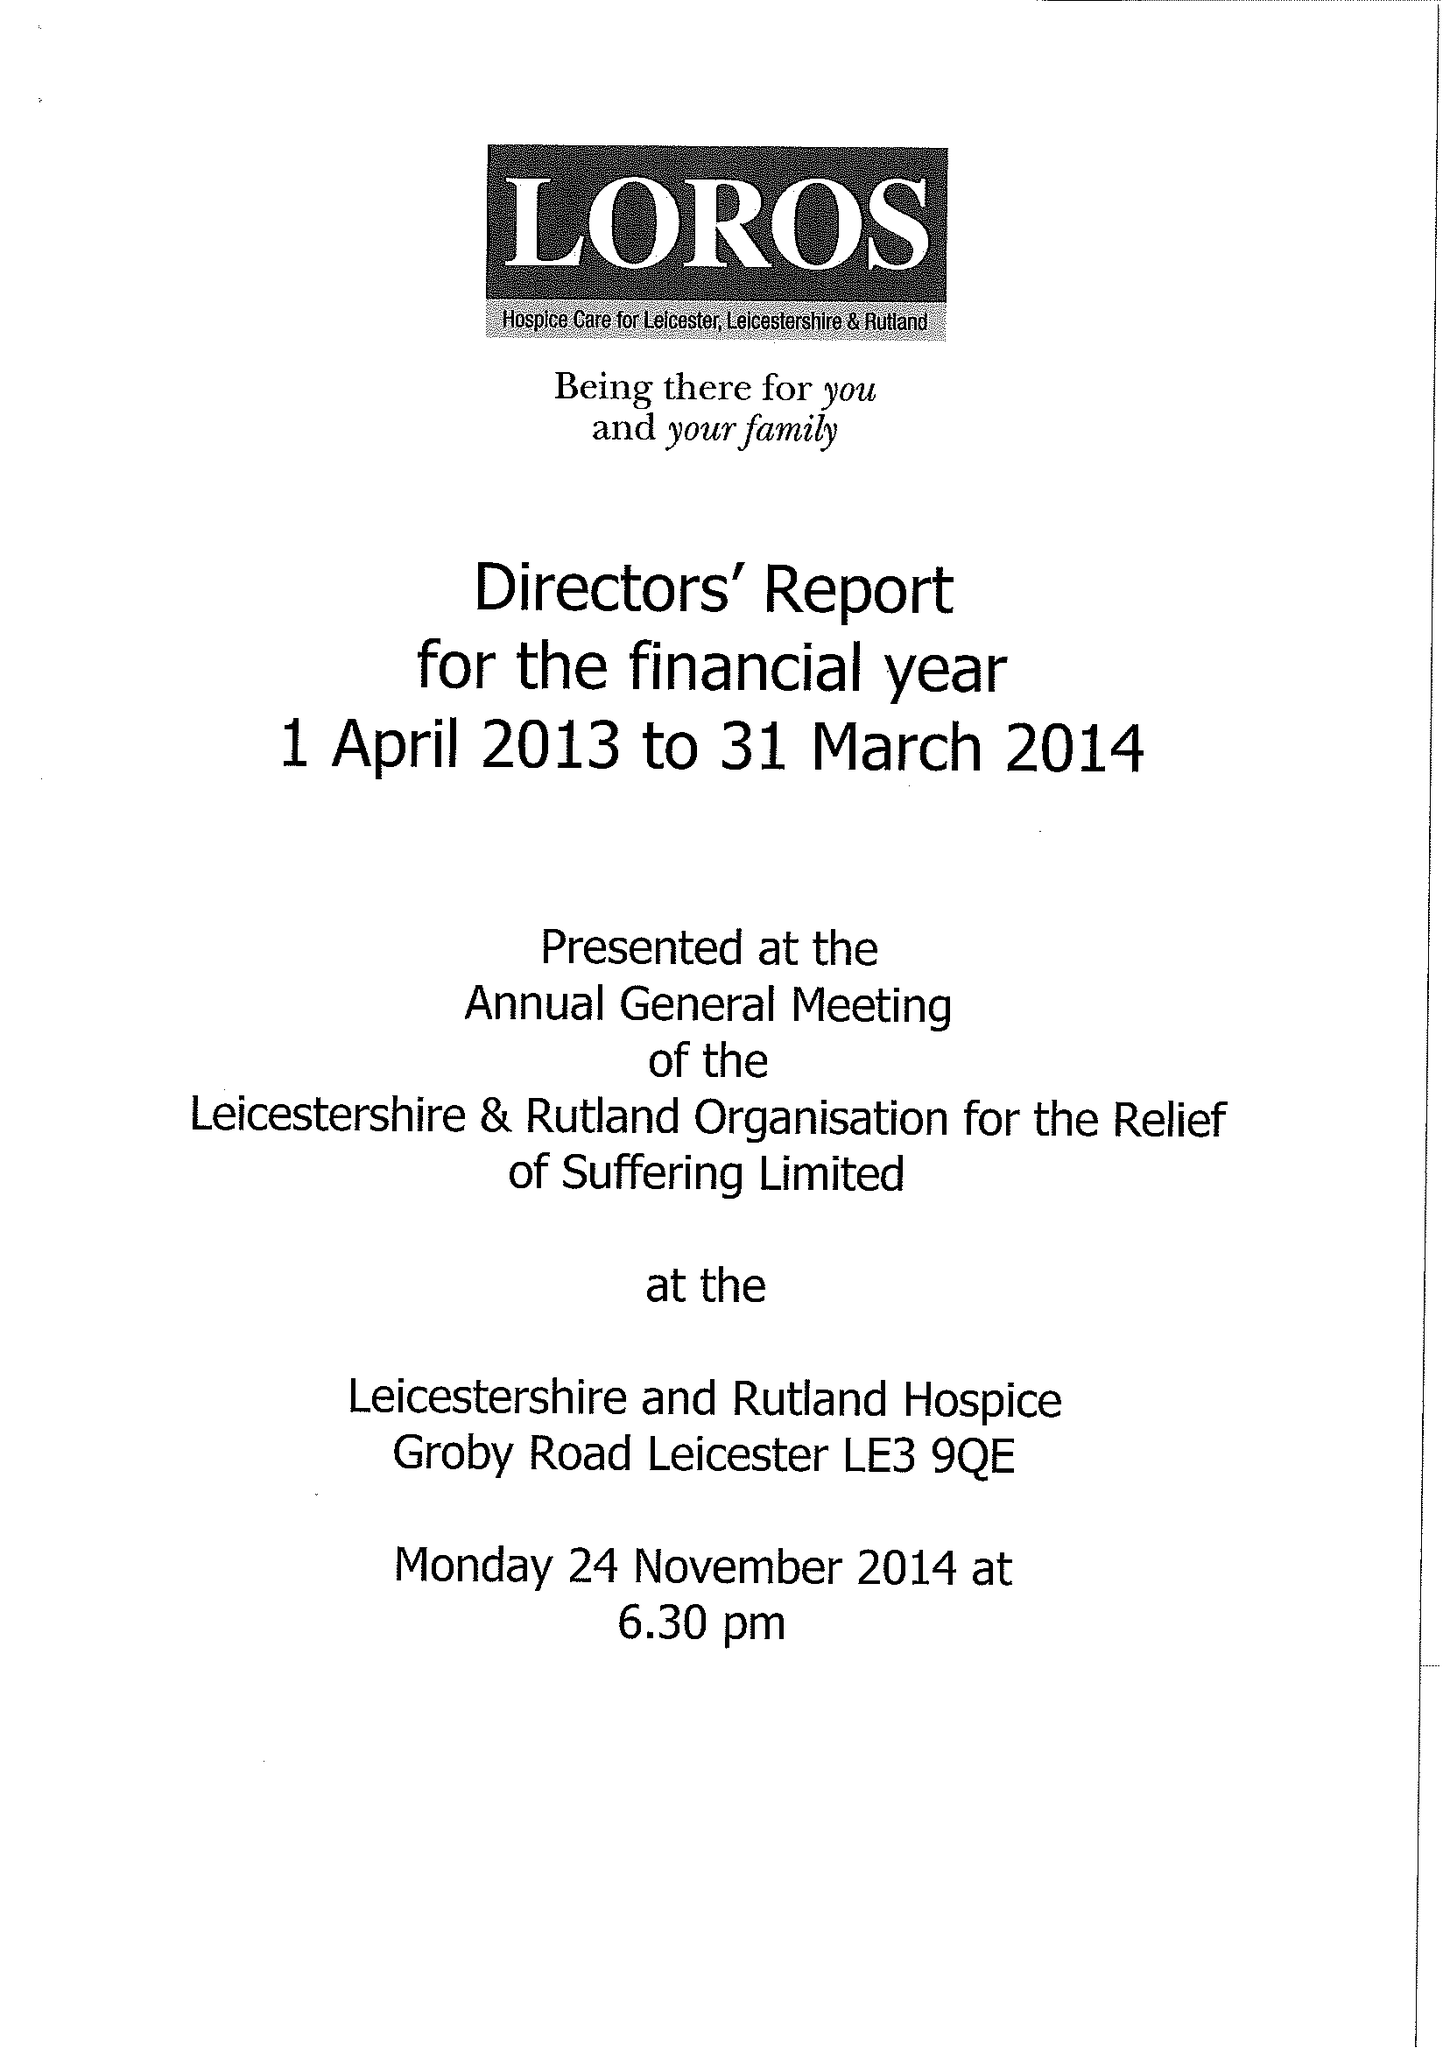What is the value for the report_date?
Answer the question using a single word or phrase. 2014-03-31 